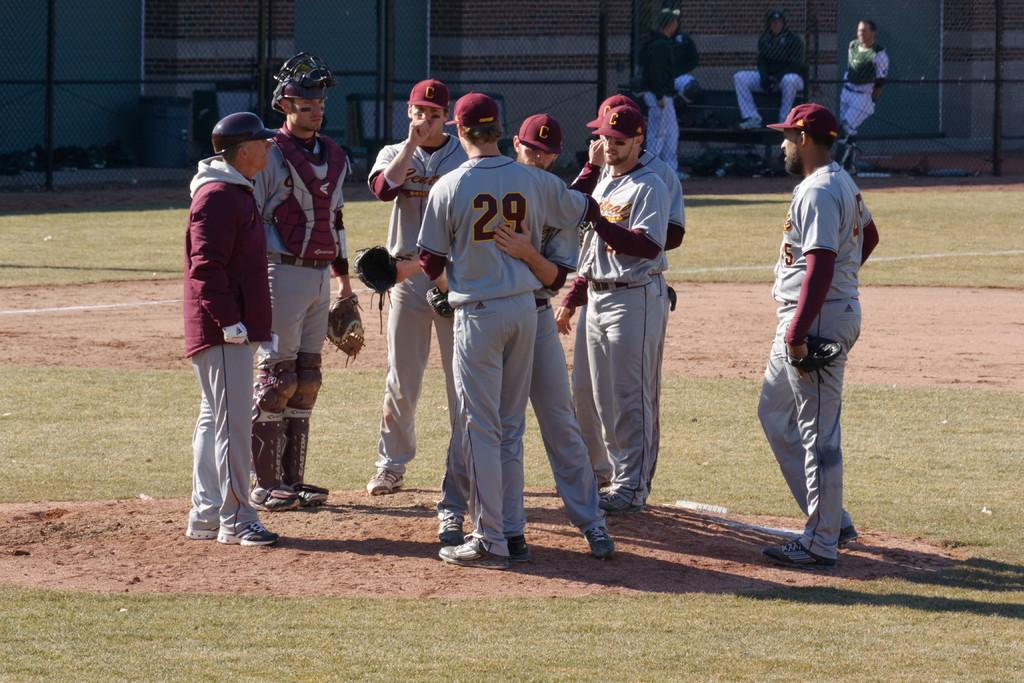<image>
Render a clear and concise summary of the photo. A baseball player has the number 29 on the back of his jersey. 